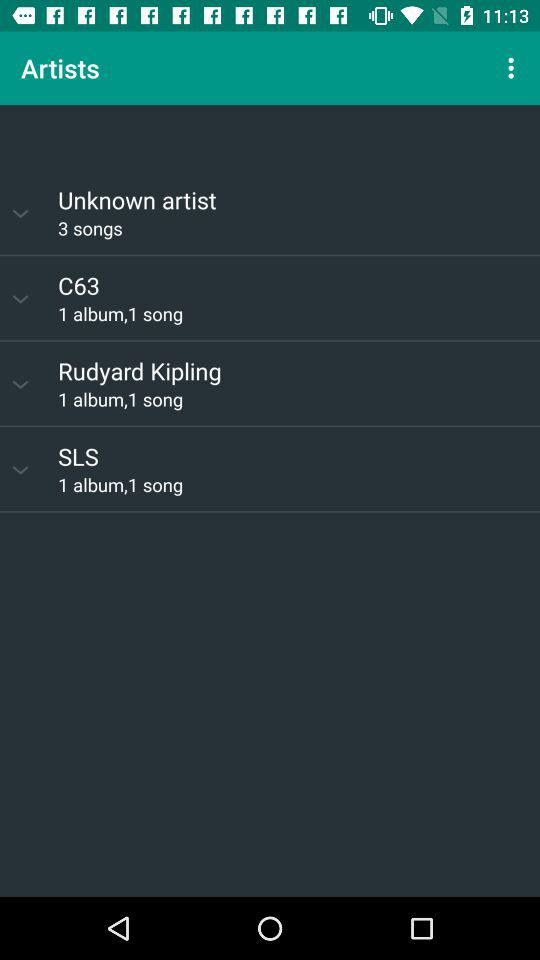How many songs are available by unknown artists? There are 3 available songs by unknown artists. 